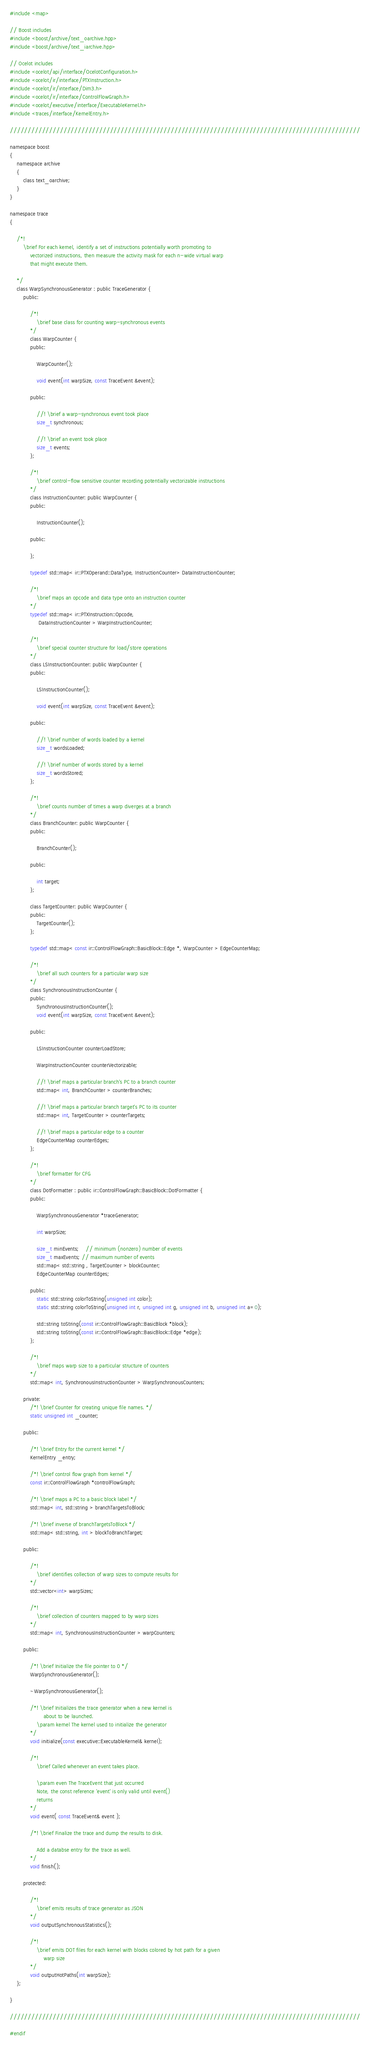<code> <loc_0><loc_0><loc_500><loc_500><_C_>#include <map>

// Boost includes
#include <boost/archive/text_oarchive.hpp>
#include <boost/archive/text_iarchive.hpp>

// Ocelot includes
#include <ocelot/api/interface/OcelotConfiguration.h>
#include <ocelot/ir/interface/PTXInstruction.h>
#include <ocelot/ir/interface/Dim3.h>
#include <ocelot/ir/interface/ControlFlowGraph.h>
#include <ocelot/executive/interface/ExecutableKernel.h>
#include <traces/interface/KernelEntry.h>

//////////////////////////////////////////////////////////////////////////////////////////////////

namespace boost
{
	namespace archive
	{
		class text_oarchive;
	}
}

namespace trace
{
	
	/*!
		\brief For each kernel, identify a set of instructions potentially worth promoting to
			vectorized instructions, then measure the activity mask for each n-wide virtual warp
			that might execute them.

	*/
	class WarpSynchronousGenerator : public TraceGenerator {
		public:
			
			/*!
				\brief base class for counting warp-synchronous events
			*/
			class WarpCounter {
			public:

				WarpCounter();

				void event(int warpSize, const TraceEvent &event);

			public:

				//! \brief a warp-synchronous event took place
				size_t synchronous;

				//! \brief an event took place
				size_t events;
			};
			
			/*!
				\brief control-flow sensitive counter recording potentially vectorizable instructions
			*/
			class InstructionCounter: public WarpCounter {
			public:

				InstructionCounter();

			public:

			};
			
			typedef std::map< ir::PTXOperand::DataType, InstructionCounter> DataInstructionCounter;

			/*!
				\brief maps an opcode and data type onto an instruction counter
			*/
			typedef std::map< ir::PTXInstruction::Opcode, 
				 DataInstructionCounter > WarpInstructionCounter;
			
			/*!
				\brief special counter structure for load/store operations
			*/
			class LSInstructionCounter: public WarpCounter {
			public:

				LSInstructionCounter();

				void event(int warpSize, const TraceEvent &event);

			public:
				
				//! \brief number of words loaded by a kernel
				size_t wordsLoaded;
				
				//! \brief number of words stored by a kernel
				size_t wordsStored;
			};

			/*!
				\brief counts number of times a warp diverges at a branch
			*/
			class BranchCounter: public WarpCounter {
			public:

				BranchCounter();

			public:

				int target;
			};

			class TargetCounter: public WarpCounter {
			public:
				TargetCounter();
			};
			
			typedef std::map< const ir::ControlFlowGraph::BasicBlock::Edge *, WarpCounter > EdgeCounterMap;

			/*!
				\brief all such counters for a particular warp size
			*/
			class SynchronousInstructionCounter {
			public:
				SynchronousInstructionCounter();
				void event(int warpSize, const TraceEvent &event);

			public:
			
				LSInstructionCounter counterLoadStore;
				
				WarpInstructionCounter counterVectorizable;

				//! \brief maps a particular branch's PC to a branch counter
				std::map< int, BranchCounter > counterBranches;

				//! \brief maps a particular branch target's PC to its counter
				std::map< int, TargetCounter > counterTargets;

				//! \brief maps a particular edge to a counter
				EdgeCounterMap counterEdges;
			};

			/*!
				\brief formatter for CFG
			*/
			class DotFormatter : public ir::ControlFlowGraph::BasicBlock::DotFormatter {
			public:
	
				WarpSynchronousGenerator *traceGenerator;

				int warpSize;

				size_t minEvents;	// minimum (nonzero) number of events
				size_t maxEvents; // maximum number of events
				std::map< std::string , TargetCounter > blockCounter;
				EdgeCounterMap counterEdges;

			public:
				static std::string colorToString(unsigned int color);
				static std::string colorToString(unsigned int r, unsigned int g, unsigned int b, unsigned int a=0);

				std::string toString(const ir::ControlFlowGraph::BasicBlock *block);
				std::string toString(const ir::ControlFlowGraph::BasicBlock::Edge *edge);
			};
			
			/*! 
				\brief maps warp size to a particular structure of counters
			*/
			std::map< int, SynchronousInstructionCounter > WarpSynchronousCounters;

		private:
			/*! \brief Counter for creating unique file names. */
			static unsigned int _counter;
		
		public:

			/*!	\brief Entry for the current kernel	*/
			KernelEntry _entry;

			/*! \brief control flow graph from kernel */
			const ir::ControlFlowGraph *controlFlowGraph;

			/*! \brief maps a PC to a basic block label */
			std::map< int, std::string > branchTargetsToBlock;

			/*! \brief inverse of branchTargetsToBlock */
			std::map< std::string, int > blockToBranchTarget;
			
		public:
		
			/*!
				\brief identifies collection of warp sizes to compute results for
			*/
			std::vector<int> warpSizes;

			/*!
				\brief collection of counters mapped to by warp sizes
			*/
			std::map< int, SynchronousInstructionCounter > warpCounters;
			
		public:
		
			/*!	\brief Initialize the file pointer to 0 */
			WarpSynchronousGenerator();
			
			~WarpSynchronousGenerator();
		
			/*!	\brief Initializes the trace generator when a new kernel is 
					about to be launched.
				\param kernel The kernel used to initialize the generator
			*/
			void initialize(const executive::ExecutableKernel& kernel);

			/*!
				\brief Called whenever an event takes place.

				\param even The TraceEvent that just occurred
				Note, the const reference 'event' is only valid until event() 
				returns
			*/
			void event( const TraceEvent& event );
			
			/*!	\brief Finalize the trace and dump the results to disk.
				
				Add a databse entry for the trace as well.
			*/
			void finish();

		protected:

			/*!
				\brief emits results of trace generator as JSON
			*/
			void outputSynchronousStatistics();

			/*!
				\brief emits DOT files for each kernel with blocks colored by hot path for a given
					warp size
			*/
			void outputHotPaths(int warpSize);
	};
	
}

//////////////////////////////////////////////////////////////////////////////////////////////////

#endif

</code> 